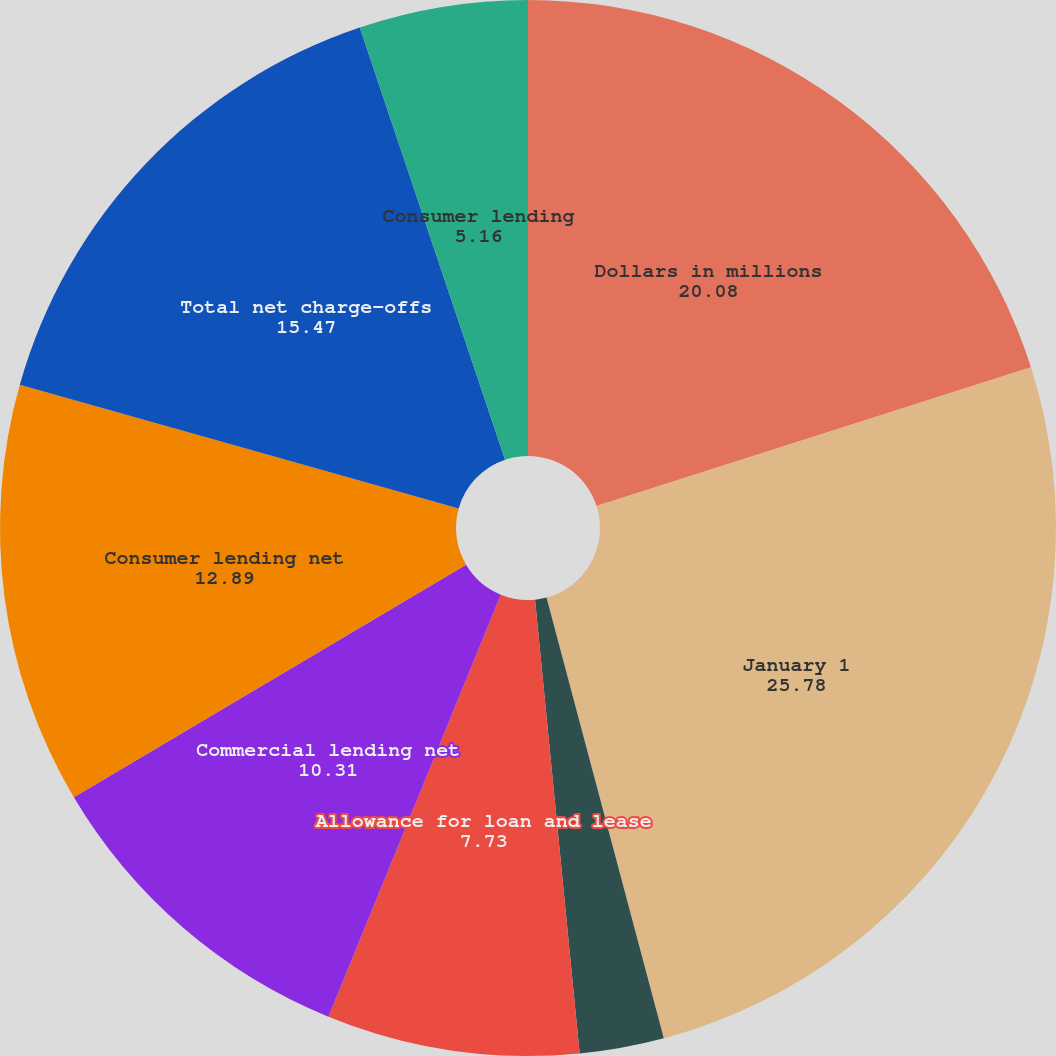<chart> <loc_0><loc_0><loc_500><loc_500><pie_chart><fcel>Dollars in millions<fcel>January 1<fcel>December 31 Net charge-offs to<fcel>Allowance for loan and lease<fcel>Commercial lending net<fcel>Consumer lending net<fcel>Total net charge-offs<fcel>Commercial lending<fcel>Consumer lending<nl><fcel>20.08%<fcel>25.78%<fcel>2.58%<fcel>7.73%<fcel>10.31%<fcel>12.89%<fcel>15.47%<fcel>0.0%<fcel>5.16%<nl></chart> 